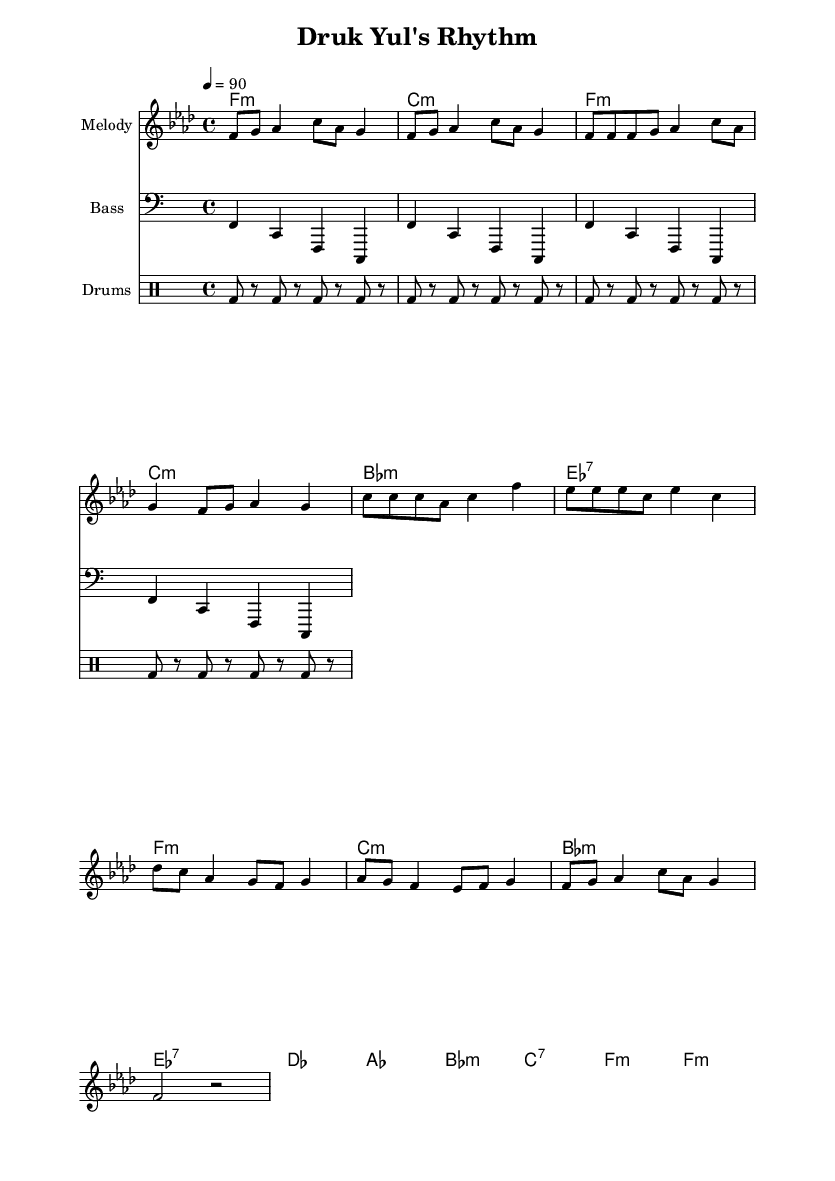What is the key signature of this music? The key signature is F minor, which can be identified by the presence of four flats on the staff.
Answer: F minor What is the time signature of this piece? The time signature is 4/4, which is indicated at the beginning of the score and shows that there are four beats in each measure.
Answer: 4/4 What is the tempo marking for this music? The tempo marking states "4 = 90," which means that there are 90 quarter-note beats per minute.
Answer: 90 How many measures are in the verse section? The verse consists of 4 measures, as you can count each line of music corresponds to a measure, and there are two lines in the verse section indicated.
Answer: 4 What type of drum pattern is used in this piece? The drum pattern consists mostly of bass drums (bd) played in a repeating rhythm, which suits hip hop music's characteristic beats.
Answer: Bass drum pattern What musical form does the piece follow? The piece follows a verse-chorus-bridge structure, commonly found in hip hop, with sections labeled for easy identification throughout the sheet music.
Answer: Verse-chorus-bridge What is the function of the bass pattern in this hip hop piece? The bass pattern supports the harmonic structure and complements the beat, providing a foundation which is typical in hip hop music to create a groove.
Answer: Foundation 